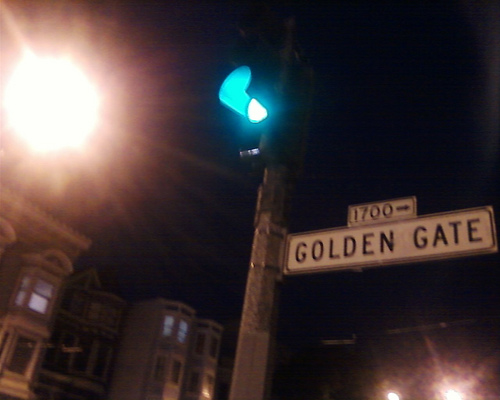Read and extract the text from this image. 1700 GOLDEN GATE 